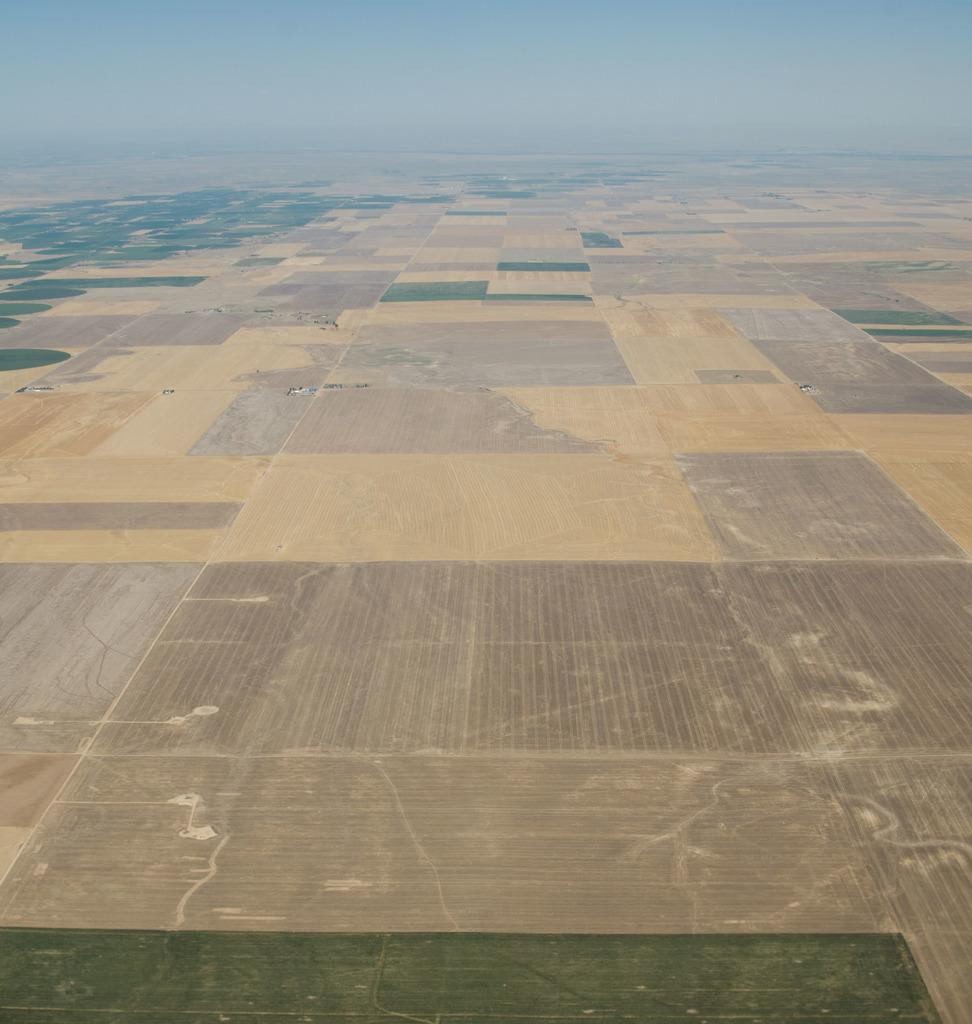What type of photograph is shown in the image? The image is an aerial photograph. What can be seen in the sky in the image? The sky is visible at the top of the image. What type of surface is visible in the image? There is grass on the surface in the image. Where is the library located in the image? There is no library present in the image; it is an aerial photograph of a grassy surface. 